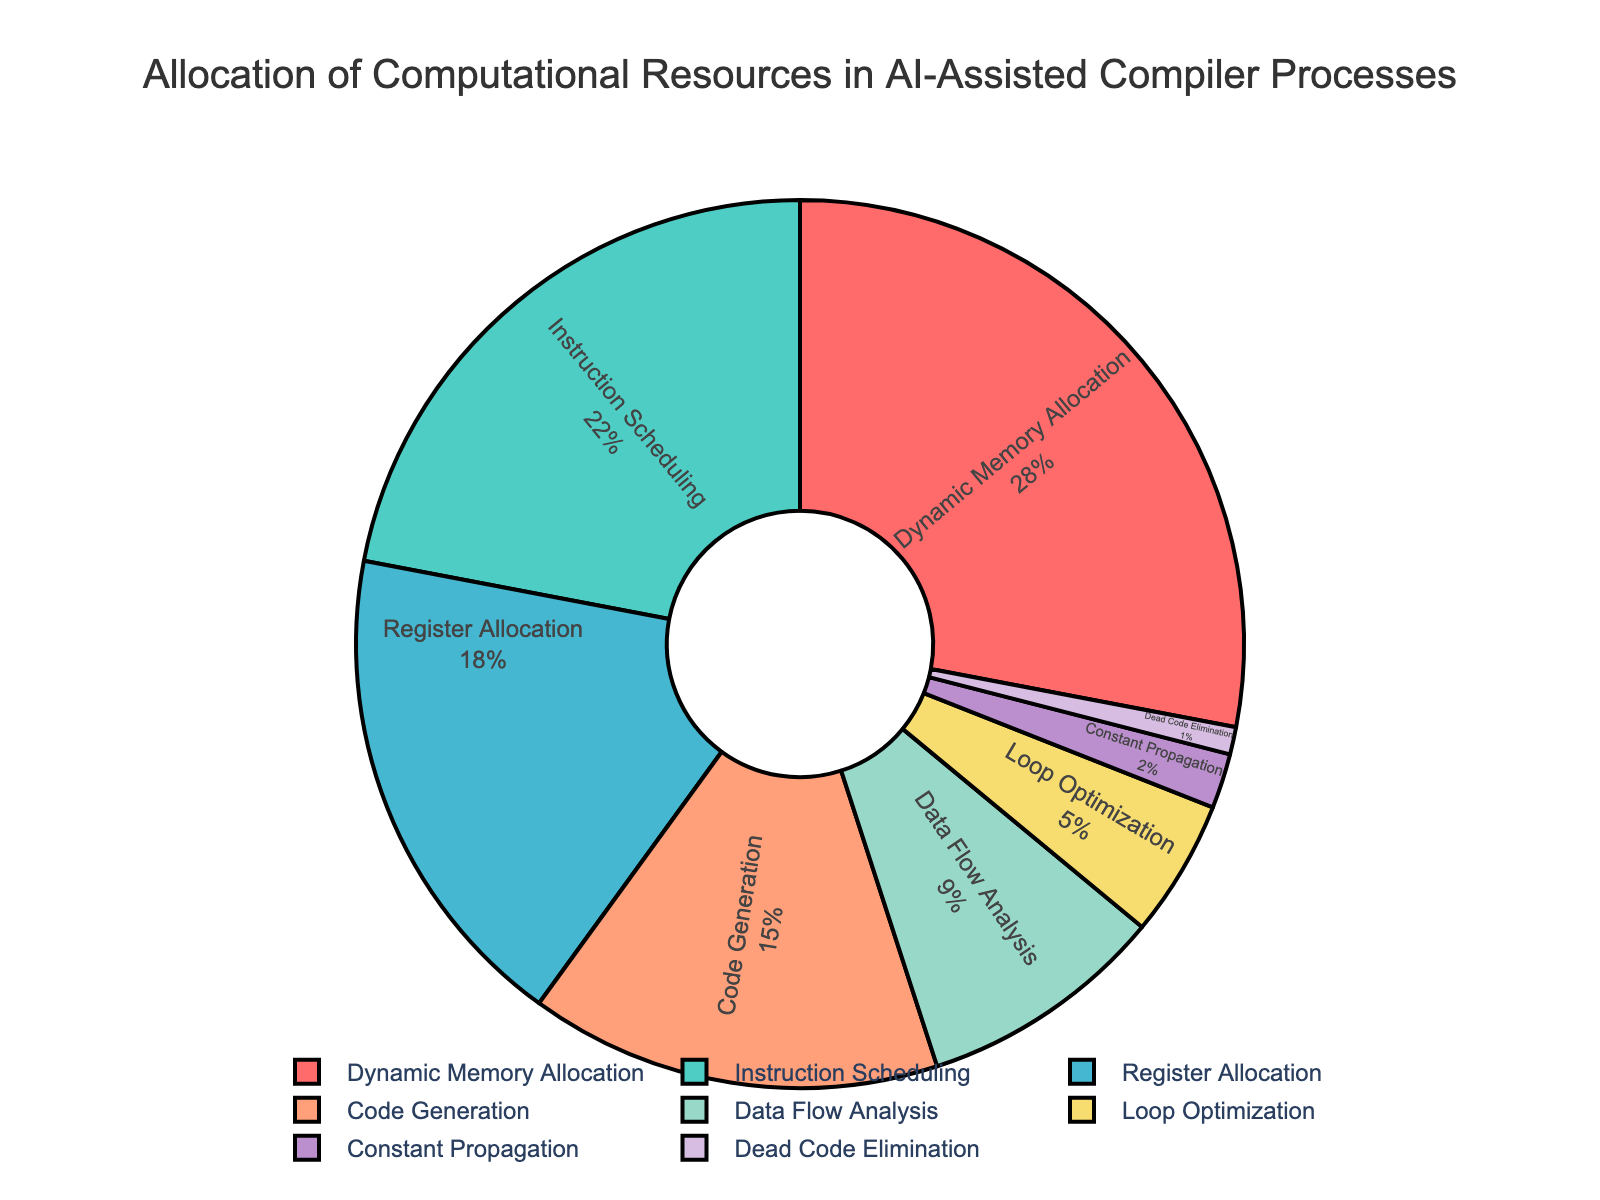What's the largest allocation of computational resources? The segment with the largest percentage will represent the largest allocation. Here, "Dynamic Memory Allocation" has the largest slice at 28%.
Answer: Dynamic Memory Allocation Which two processes together account for over 50% of the resources? By adding their percentages, we find that "Dynamic Memory Allocation" (28%) and "Instruction Scheduling" (22%) together make 50%. These two account for the largest combined resources.
Answer: Dynamic Memory Allocation and Instruction Scheduling What's the difference in resource allocation between Code Generation and Register Allocation? Subtract the percentage of "Register Allocation" from "Code Generation". "Code Generation" is 15%, and "Register Allocation" is 18%, so the difference is 18% - 15% = 3%.
Answer: 3% Which resource has the smallest allocation? The smallest slice on the pie chart represents the smallest allocation. Here, "Dead Code Elimination" has 1%, which is the smallest.
Answer: Dead Code Elimination Is Loop Optimization allocated more resources than Data Flow Analysis? Comparing their percentages, "Data Flow Analysis" has 9%, and "Loop Optimization" has 5%, meaning Loop Optimization has fewer resources.
Answer: No What percentage of the resources is allocated to Constant Propagation and Dead Code Elimination together? Adding the percentages of "Constant Propagation" (2%) and "Dead Code Elimination" (1%) gives 2% + 1% = 3%.
Answer: 3% How much more is assigned to Dynamic Memory Allocation than Code Generation? Subtract the percentage of "Code Generation" from "Dynamic Memory Allocation". "Dynamic Memory Allocation" is 28%, and "Code Generation" is 15%, so the difference is 28% - 15% = 13%.
Answer: 13% What is the sum of the percentages for the top three resource allocations? The top three resource allocations are Dynamic Memory Allocation (28%), Instruction Scheduling (22%), and Register Allocation (18%). Adding these gives 28% + 22% + 18% = 68%.
Answer: 68% Which resource has a slice in dark purple color, and what is its allocation percentage? The dark purple color represents "Code Generation". Checking the chart, this resource has an allocation of 15%.
Answer: Code Generation, 15% Is Register Allocation the third largest slice, and if so, what is its percentage? Observing the pie chart, the third largest slice by size corresponds to "Register Allocation", which has a percentage of 18%.
Answer: Yes, 18% 